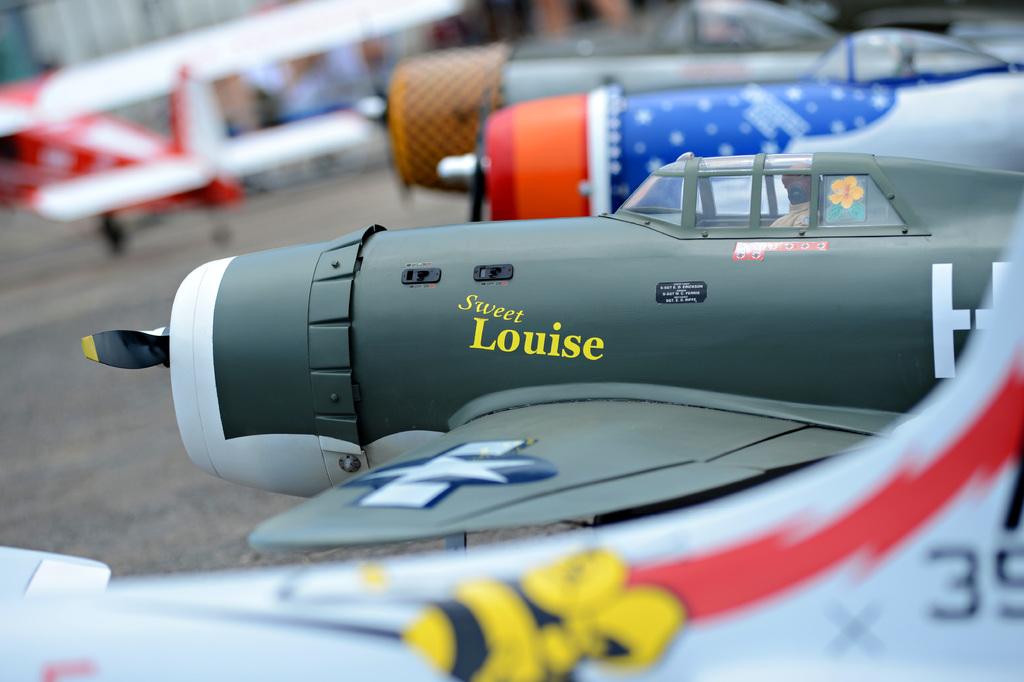What girl's name is found on the plane?
Keep it short and to the point. Louise. What number is visible on the white plane?
Provide a short and direct response. 35. 